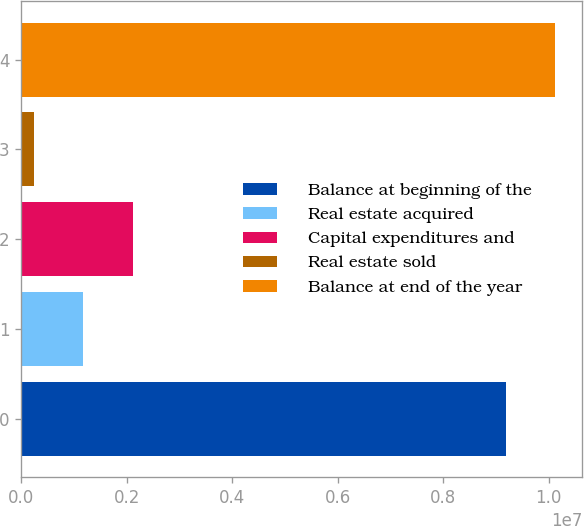Convert chart. <chart><loc_0><loc_0><loc_500><loc_500><bar_chart><fcel>Balance at beginning of the<fcel>Real estate acquired<fcel>Capital expenditures and<fcel>Real estate sold<fcel>Balance at end of the year<nl><fcel>9.19028e+06<fcel>1.17617e+06<fcel>2.1139e+06<fcel>238440<fcel>1.0128e+07<nl></chart> 